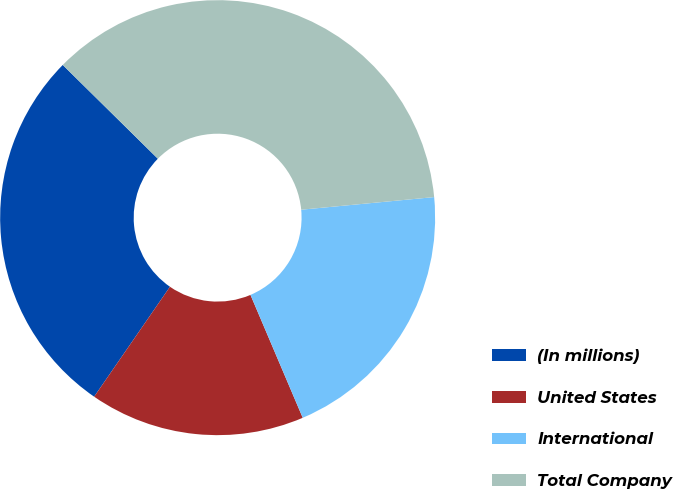Convert chart. <chart><loc_0><loc_0><loc_500><loc_500><pie_chart><fcel>(In millions)<fcel>United States<fcel>International<fcel>Total Company<nl><fcel>27.78%<fcel>16.01%<fcel>20.11%<fcel>36.11%<nl></chart> 